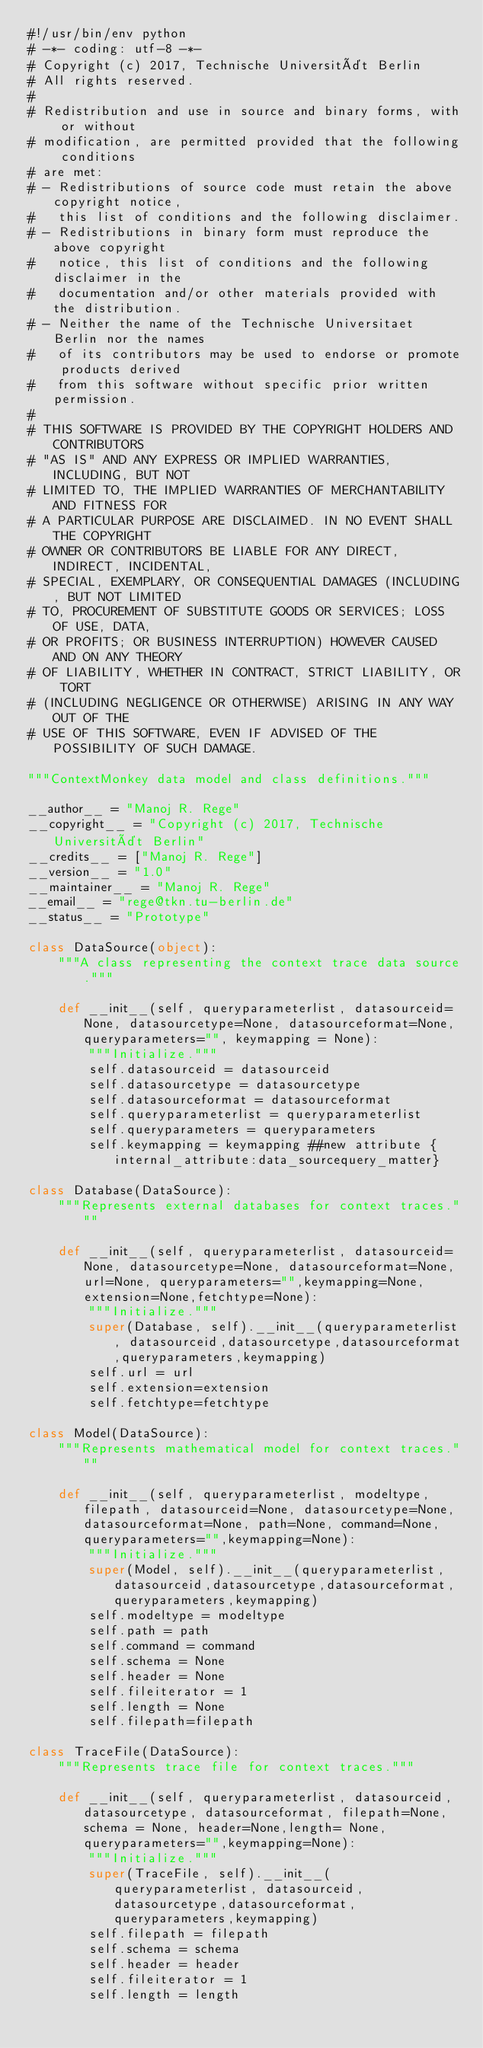Convert code to text. <code><loc_0><loc_0><loc_500><loc_500><_Python_>#!/usr/bin/env python
# -*- coding: utf-8 -*-
# Copyright (c) 2017, Technische Universität Berlin
# All rights reserved.
#
# Redistribution and use in source and binary forms, with or without
# modification, are permitted provided that the following conditions
# are met:
# - Redistributions of source code must retain the above copyright notice,
#   this list of conditions and the following disclaimer.
# - Redistributions in binary form must reproduce the above copyright
#   notice, this list of conditions and the following disclaimer in the
#   documentation and/or other materials provided with the distribution.
# - Neither the name of the Technische Universitaet Berlin nor the names
#   of its contributors may be used to endorse or promote products derived
#   from this software without specific prior written permission.
#
# THIS SOFTWARE IS PROVIDED BY THE COPYRIGHT HOLDERS AND CONTRIBUTORS
# "AS IS" AND ANY EXPRESS OR IMPLIED WARRANTIES, INCLUDING, BUT NOT
# LIMITED TO, THE IMPLIED WARRANTIES OF MERCHANTABILITY AND FITNESS FOR
# A PARTICULAR PURPOSE ARE DISCLAIMED. IN NO EVENT SHALL THE COPYRIGHT
# OWNER OR CONTRIBUTORS BE LIABLE FOR ANY DIRECT, INDIRECT, INCIDENTAL,
# SPECIAL, EXEMPLARY, OR CONSEQUENTIAL DAMAGES (INCLUDING, BUT NOT LIMITED
# TO, PROCUREMENT OF SUBSTITUTE GOODS OR SERVICES; LOSS OF USE, DATA,
# OR PROFITS; OR BUSINESS INTERRUPTION) HOWEVER CAUSED AND ON ANY THEORY
# OF LIABILITY, WHETHER IN CONTRACT, STRICT LIABILITY, OR TORT
# (INCLUDING NEGLIGENCE OR OTHERWISE) ARISING IN ANY WAY OUT OF THE
# USE OF THIS SOFTWARE, EVEN IF ADVISED OF THE POSSIBILITY OF SUCH DAMAGE.

"""ContextMonkey data model and class definitions."""

__author__ = "Manoj R. Rege"
__copyright__ = "Copyright (c) 2017, Technische Universität Berlin"
__credits__ = ["Manoj R. Rege"]
__version__ = "1.0"
__maintainer__ = "Manoj R. Rege"
__email__ = "rege@tkn.tu-berlin.de"
__status__ = "Prototype"

class DataSource(object):
    """A class representing the context trace data source."""
    
    def __init__(self, queryparameterlist, datasourceid=None, datasourcetype=None, datasourceformat=None, queryparameters="", keymapping = None):
        """Initialize."""
        self.datasourceid = datasourceid
        self.datasourcetype = datasourcetype
        self.datasourceformat = datasourceformat
        self.queryparameterlist = queryparameterlist
        self.queryparameters = queryparameters
        self.keymapping = keymapping ##new attribute {internal_attribute:data_sourcequery_matter}

class Database(DataSource):
    """Represents external databases for context traces."""
    
    def __init__(self, queryparameterlist, datasourceid=None, datasourcetype=None, datasourceformat=None, url=None, queryparameters="",keymapping=None,extension=None,fetchtype=None):
        """Initialize."""
        super(Database, self).__init__(queryparameterlist, datasourceid,datasourcetype,datasourceformat,queryparameters,keymapping)
        self.url = url
        self.extension=extension
        self.fetchtype=fetchtype

class Model(DataSource):
    """Represents mathematical model for context traces."""
    
    def __init__(self, queryparameterlist, modeltype, filepath, datasourceid=None, datasourcetype=None, datasourceformat=None, path=None, command=None, queryparameters="",keymapping=None):
        """Initialize."""
        super(Model, self).__init__(queryparameterlist, datasourceid,datasourcetype,datasourceformat,queryparameters,keymapping)
        self.modeltype = modeltype
        self.path = path
        self.command = command
        self.schema = None
        self.header = None
        self.fileiterator = 1
        self.length = None
        self.filepath=filepath

class TraceFile(DataSource):
    """Represents trace file for context traces."""
    
    def __init__(self, queryparameterlist, datasourceid, datasourcetype, datasourceformat, filepath=None, schema = None, header=None,length= None, queryparameters="",keymapping=None):
        """Initialize."""
        super(TraceFile, self).__init__(queryparameterlist, datasourceid,datasourcetype,datasourceformat,queryparameters,keymapping)
        self.filepath = filepath
        self.schema = schema
        self.header = header
        self.fileiterator = 1
        self.length = length
</code> 